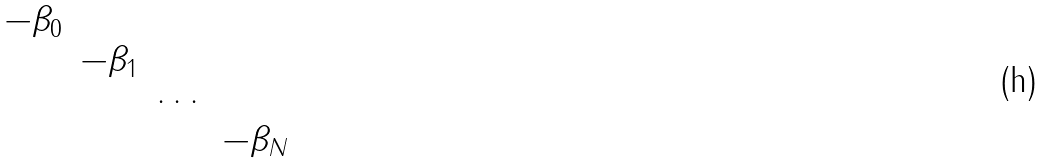Convert formula to latex. <formula><loc_0><loc_0><loc_500><loc_500>\begin{matrix} - \beta _ { 0 } & & & \\ & - \beta _ { 1 } & & \\ & & \cdots & \\ & & & - \beta _ { N } \\ \end{matrix}</formula> 